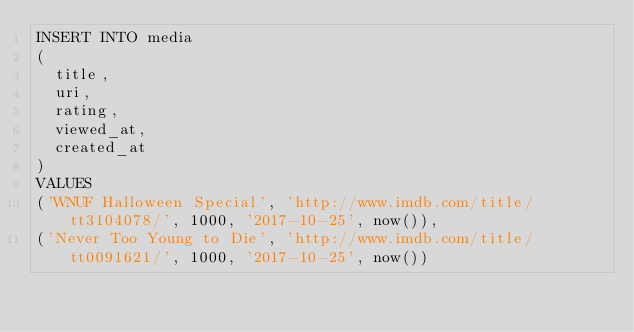Convert code to text. <code><loc_0><loc_0><loc_500><loc_500><_SQL_>INSERT INTO media
(
  title,
  uri,
  rating,
  viewed_at,
  created_at
)
VALUES
('WNUF Halloween Special', 'http://www.imdb.com/title/tt3104078/', 1000, '2017-10-25', now()),
('Never Too Young to Die', 'http://www.imdb.com/title/tt0091621/', 1000, '2017-10-25', now())
</code> 